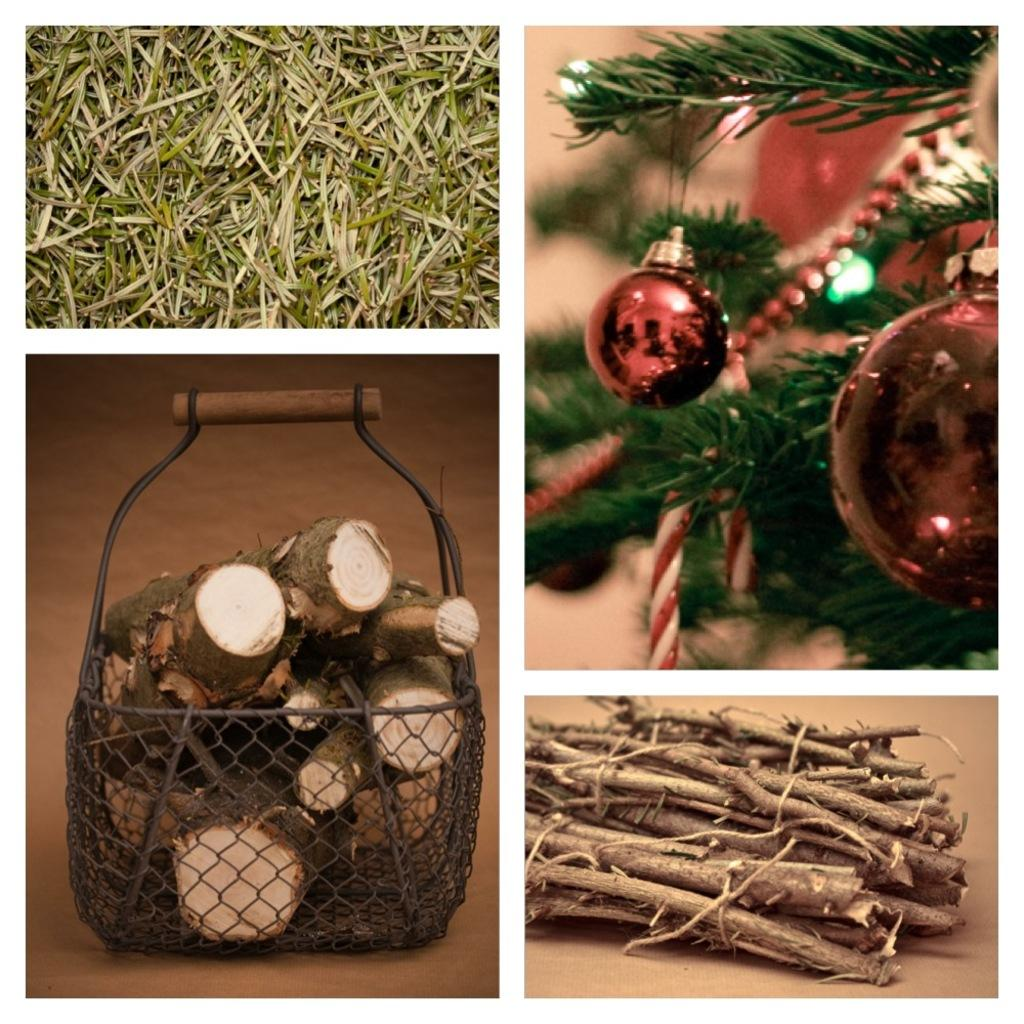What type of tree is in the image? There is a Christmas tree in the image. What type of vegetation is visible in the image? There is grass visible in the image. What objects are made of wood and present in the image? There are wood sticks in a basket and on the floor in the image. What type of war is depicted in the image? There is no war depicted in the image; it features a Christmas tree, grass, and wood sticks. What type of flame can be seen in the image? There is no flame present in the image. 